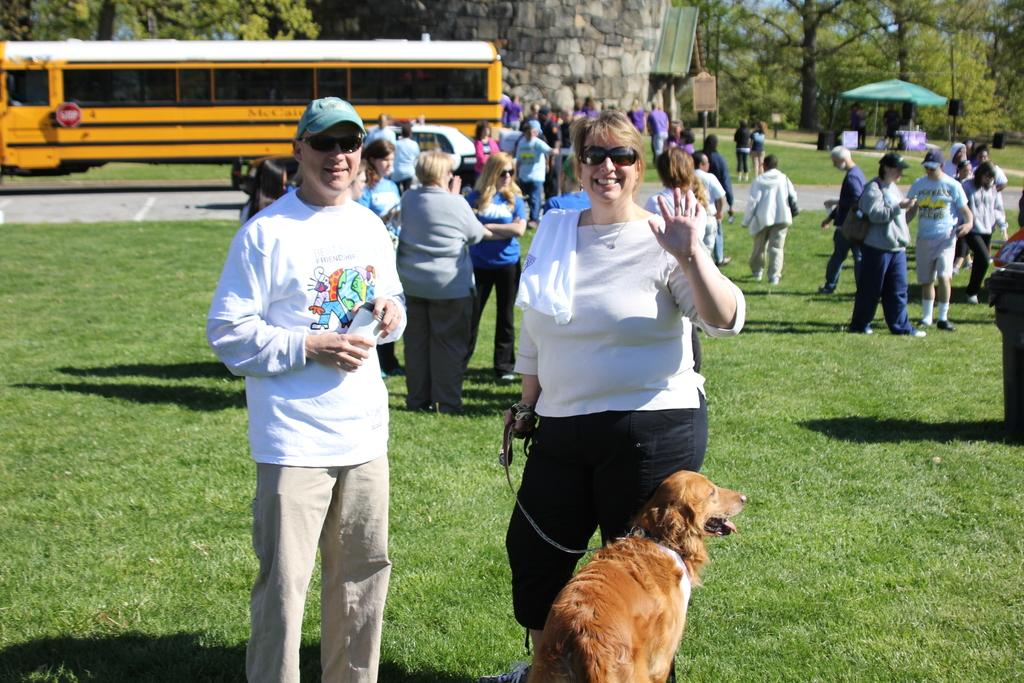What is the surface that the people are standing on in the image? The people are standing on grass in the image. What is the woman holding in the image? The woman is holding a dog in the image. What type of vehicle can be seen in the image? There is a bus parked at one corner of the image. Can you see a cat wearing a crown in the image? There is no cat or crown present in the image. Is there a jail visible in the image? There is no jail present in the image. 